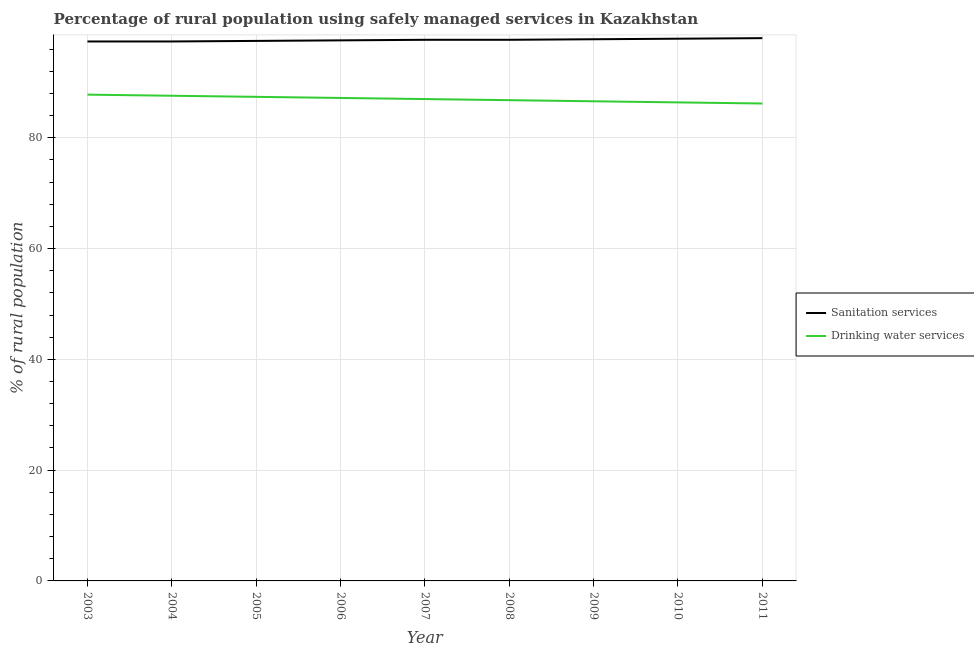What is the percentage of rural population who used drinking water services in 2006?
Offer a very short reply. 87.2. Across all years, what is the maximum percentage of rural population who used drinking water services?
Your response must be concise. 87.8. Across all years, what is the minimum percentage of rural population who used drinking water services?
Your answer should be very brief. 86.2. In which year was the percentage of rural population who used sanitation services minimum?
Your response must be concise. 2003. What is the total percentage of rural population who used drinking water services in the graph?
Offer a very short reply. 783. What is the difference between the percentage of rural population who used sanitation services in 2006 and that in 2010?
Your response must be concise. -0.3. What is the difference between the percentage of rural population who used drinking water services in 2010 and the percentage of rural population who used sanitation services in 2005?
Offer a very short reply. -11.1. What is the average percentage of rural population who used sanitation services per year?
Give a very brief answer. 97.67. In the year 2005, what is the difference between the percentage of rural population who used sanitation services and percentage of rural population who used drinking water services?
Your answer should be very brief. 10.1. What is the ratio of the percentage of rural population who used drinking water services in 2003 to that in 2009?
Ensure brevity in your answer.  1.01. What is the difference between the highest and the second highest percentage of rural population who used drinking water services?
Give a very brief answer. 0.2. What is the difference between the highest and the lowest percentage of rural population who used sanitation services?
Keep it short and to the point. 0.6. Does the percentage of rural population who used sanitation services monotonically increase over the years?
Your response must be concise. No. Is the percentage of rural population who used sanitation services strictly less than the percentage of rural population who used drinking water services over the years?
Offer a terse response. No. How many lines are there?
Offer a terse response. 2. How many years are there in the graph?
Offer a very short reply. 9. What is the difference between two consecutive major ticks on the Y-axis?
Give a very brief answer. 20. Does the graph contain grids?
Your answer should be very brief. Yes. How are the legend labels stacked?
Offer a very short reply. Vertical. What is the title of the graph?
Provide a short and direct response. Percentage of rural population using safely managed services in Kazakhstan. Does "Constant 2005 US$" appear as one of the legend labels in the graph?
Ensure brevity in your answer.  No. What is the label or title of the X-axis?
Keep it short and to the point. Year. What is the label or title of the Y-axis?
Your answer should be very brief. % of rural population. What is the % of rural population of Sanitation services in 2003?
Ensure brevity in your answer.  97.4. What is the % of rural population in Drinking water services in 2003?
Ensure brevity in your answer.  87.8. What is the % of rural population in Sanitation services in 2004?
Provide a short and direct response. 97.4. What is the % of rural population of Drinking water services in 2004?
Give a very brief answer. 87.6. What is the % of rural population of Sanitation services in 2005?
Provide a short and direct response. 97.5. What is the % of rural population of Drinking water services in 2005?
Make the answer very short. 87.4. What is the % of rural population in Sanitation services in 2006?
Give a very brief answer. 97.6. What is the % of rural population of Drinking water services in 2006?
Offer a terse response. 87.2. What is the % of rural population of Sanitation services in 2007?
Make the answer very short. 97.7. What is the % of rural population of Sanitation services in 2008?
Give a very brief answer. 97.7. What is the % of rural population in Drinking water services in 2008?
Ensure brevity in your answer.  86.8. What is the % of rural population in Sanitation services in 2009?
Ensure brevity in your answer.  97.8. What is the % of rural population in Drinking water services in 2009?
Offer a very short reply. 86.6. What is the % of rural population of Sanitation services in 2010?
Offer a very short reply. 97.9. What is the % of rural population of Drinking water services in 2010?
Your answer should be very brief. 86.4. What is the % of rural population in Drinking water services in 2011?
Provide a short and direct response. 86.2. Across all years, what is the maximum % of rural population in Sanitation services?
Your answer should be compact. 98. Across all years, what is the maximum % of rural population of Drinking water services?
Offer a terse response. 87.8. Across all years, what is the minimum % of rural population in Sanitation services?
Ensure brevity in your answer.  97.4. Across all years, what is the minimum % of rural population in Drinking water services?
Make the answer very short. 86.2. What is the total % of rural population in Sanitation services in the graph?
Offer a very short reply. 879. What is the total % of rural population of Drinking water services in the graph?
Keep it short and to the point. 783. What is the difference between the % of rural population of Sanitation services in 2003 and that in 2004?
Ensure brevity in your answer.  0. What is the difference between the % of rural population of Sanitation services in 2003 and that in 2005?
Your answer should be very brief. -0.1. What is the difference between the % of rural population in Sanitation services in 2003 and that in 2008?
Provide a short and direct response. -0.3. What is the difference between the % of rural population of Drinking water services in 2003 and that in 2008?
Provide a succinct answer. 1. What is the difference between the % of rural population of Sanitation services in 2003 and that in 2010?
Your response must be concise. -0.5. What is the difference between the % of rural population in Drinking water services in 2003 and that in 2011?
Your response must be concise. 1.6. What is the difference between the % of rural population in Sanitation services in 2004 and that in 2005?
Give a very brief answer. -0.1. What is the difference between the % of rural population in Drinking water services in 2004 and that in 2007?
Make the answer very short. 0.6. What is the difference between the % of rural population of Sanitation services in 2004 and that in 2008?
Your answer should be compact. -0.3. What is the difference between the % of rural population of Drinking water services in 2004 and that in 2008?
Make the answer very short. 0.8. What is the difference between the % of rural population of Drinking water services in 2004 and that in 2009?
Offer a very short reply. 1. What is the difference between the % of rural population in Sanitation services in 2004 and that in 2011?
Give a very brief answer. -0.6. What is the difference between the % of rural population in Drinking water services in 2004 and that in 2011?
Make the answer very short. 1.4. What is the difference between the % of rural population in Sanitation services in 2005 and that in 2007?
Offer a terse response. -0.2. What is the difference between the % of rural population of Drinking water services in 2005 and that in 2007?
Provide a short and direct response. 0.4. What is the difference between the % of rural population of Drinking water services in 2005 and that in 2008?
Your answer should be compact. 0.6. What is the difference between the % of rural population of Sanitation services in 2005 and that in 2009?
Provide a short and direct response. -0.3. What is the difference between the % of rural population in Drinking water services in 2005 and that in 2009?
Provide a short and direct response. 0.8. What is the difference between the % of rural population of Sanitation services in 2006 and that in 2007?
Keep it short and to the point. -0.1. What is the difference between the % of rural population in Drinking water services in 2006 and that in 2007?
Keep it short and to the point. 0.2. What is the difference between the % of rural population in Sanitation services in 2006 and that in 2008?
Give a very brief answer. -0.1. What is the difference between the % of rural population of Sanitation services in 2006 and that in 2009?
Offer a terse response. -0.2. What is the difference between the % of rural population in Sanitation services in 2006 and that in 2011?
Make the answer very short. -0.4. What is the difference between the % of rural population in Drinking water services in 2006 and that in 2011?
Ensure brevity in your answer.  1. What is the difference between the % of rural population in Drinking water services in 2007 and that in 2008?
Ensure brevity in your answer.  0.2. What is the difference between the % of rural population in Drinking water services in 2007 and that in 2009?
Your answer should be compact. 0.4. What is the difference between the % of rural population of Drinking water services in 2007 and that in 2010?
Offer a terse response. 0.6. What is the difference between the % of rural population of Sanitation services in 2007 and that in 2011?
Keep it short and to the point. -0.3. What is the difference between the % of rural population in Drinking water services in 2008 and that in 2009?
Provide a succinct answer. 0.2. What is the difference between the % of rural population in Sanitation services in 2008 and that in 2010?
Keep it short and to the point. -0.2. What is the difference between the % of rural population in Sanitation services in 2008 and that in 2011?
Your answer should be very brief. -0.3. What is the difference between the % of rural population of Drinking water services in 2008 and that in 2011?
Ensure brevity in your answer.  0.6. What is the difference between the % of rural population of Drinking water services in 2009 and that in 2010?
Provide a succinct answer. 0.2. What is the difference between the % of rural population in Sanitation services in 2009 and that in 2011?
Offer a very short reply. -0.2. What is the difference between the % of rural population in Drinking water services in 2009 and that in 2011?
Your response must be concise. 0.4. What is the difference between the % of rural population in Sanitation services in 2010 and that in 2011?
Make the answer very short. -0.1. What is the difference between the % of rural population in Drinking water services in 2010 and that in 2011?
Keep it short and to the point. 0.2. What is the difference between the % of rural population in Sanitation services in 2003 and the % of rural population in Drinking water services in 2004?
Ensure brevity in your answer.  9.8. What is the difference between the % of rural population of Sanitation services in 2003 and the % of rural population of Drinking water services in 2005?
Provide a short and direct response. 10. What is the difference between the % of rural population of Sanitation services in 2003 and the % of rural population of Drinking water services in 2007?
Provide a succinct answer. 10.4. What is the difference between the % of rural population of Sanitation services in 2003 and the % of rural population of Drinking water services in 2009?
Make the answer very short. 10.8. What is the difference between the % of rural population in Sanitation services in 2004 and the % of rural population in Drinking water services in 2005?
Your answer should be compact. 10. What is the difference between the % of rural population of Sanitation services in 2004 and the % of rural population of Drinking water services in 2007?
Offer a terse response. 10.4. What is the difference between the % of rural population of Sanitation services in 2004 and the % of rural population of Drinking water services in 2008?
Offer a terse response. 10.6. What is the difference between the % of rural population in Sanitation services in 2004 and the % of rural population in Drinking water services in 2009?
Provide a short and direct response. 10.8. What is the difference between the % of rural population of Sanitation services in 2004 and the % of rural population of Drinking water services in 2010?
Offer a terse response. 11. What is the difference between the % of rural population of Sanitation services in 2004 and the % of rural population of Drinking water services in 2011?
Provide a succinct answer. 11.2. What is the difference between the % of rural population of Sanitation services in 2005 and the % of rural population of Drinking water services in 2006?
Make the answer very short. 10.3. What is the difference between the % of rural population in Sanitation services in 2005 and the % of rural population in Drinking water services in 2009?
Make the answer very short. 10.9. What is the difference between the % of rural population of Sanitation services in 2006 and the % of rural population of Drinking water services in 2008?
Make the answer very short. 10.8. What is the difference between the % of rural population in Sanitation services in 2006 and the % of rural population in Drinking water services in 2009?
Give a very brief answer. 11. What is the difference between the % of rural population in Sanitation services in 2007 and the % of rural population in Drinking water services in 2008?
Your response must be concise. 10.9. What is the difference between the % of rural population of Sanitation services in 2008 and the % of rural population of Drinking water services in 2009?
Ensure brevity in your answer.  11.1. What is the difference between the % of rural population of Sanitation services in 2008 and the % of rural population of Drinking water services in 2010?
Give a very brief answer. 11.3. What is the difference between the % of rural population in Sanitation services in 2008 and the % of rural population in Drinking water services in 2011?
Offer a terse response. 11.5. What is the difference between the % of rural population of Sanitation services in 2009 and the % of rural population of Drinking water services in 2011?
Keep it short and to the point. 11.6. What is the difference between the % of rural population in Sanitation services in 2010 and the % of rural population in Drinking water services in 2011?
Offer a very short reply. 11.7. What is the average % of rural population of Sanitation services per year?
Ensure brevity in your answer.  97.67. In the year 2004, what is the difference between the % of rural population of Sanitation services and % of rural population of Drinking water services?
Make the answer very short. 9.8. In the year 2006, what is the difference between the % of rural population of Sanitation services and % of rural population of Drinking water services?
Offer a very short reply. 10.4. In the year 2007, what is the difference between the % of rural population of Sanitation services and % of rural population of Drinking water services?
Offer a very short reply. 10.7. In the year 2009, what is the difference between the % of rural population of Sanitation services and % of rural population of Drinking water services?
Provide a short and direct response. 11.2. In the year 2011, what is the difference between the % of rural population in Sanitation services and % of rural population in Drinking water services?
Keep it short and to the point. 11.8. What is the ratio of the % of rural population of Drinking water services in 2003 to that in 2005?
Your answer should be very brief. 1. What is the ratio of the % of rural population of Drinking water services in 2003 to that in 2006?
Ensure brevity in your answer.  1.01. What is the ratio of the % of rural population in Sanitation services in 2003 to that in 2007?
Offer a very short reply. 1. What is the ratio of the % of rural population of Drinking water services in 2003 to that in 2007?
Provide a short and direct response. 1.01. What is the ratio of the % of rural population of Drinking water services in 2003 to that in 2008?
Offer a terse response. 1.01. What is the ratio of the % of rural population of Sanitation services in 2003 to that in 2009?
Provide a succinct answer. 1. What is the ratio of the % of rural population of Drinking water services in 2003 to that in 2009?
Keep it short and to the point. 1.01. What is the ratio of the % of rural population of Drinking water services in 2003 to that in 2010?
Keep it short and to the point. 1.02. What is the ratio of the % of rural population in Sanitation services in 2003 to that in 2011?
Ensure brevity in your answer.  0.99. What is the ratio of the % of rural population in Drinking water services in 2003 to that in 2011?
Provide a short and direct response. 1.02. What is the ratio of the % of rural population of Sanitation services in 2004 to that in 2005?
Give a very brief answer. 1. What is the ratio of the % of rural population of Sanitation services in 2004 to that in 2006?
Ensure brevity in your answer.  1. What is the ratio of the % of rural population in Drinking water services in 2004 to that in 2006?
Your response must be concise. 1. What is the ratio of the % of rural population of Sanitation services in 2004 to that in 2007?
Offer a terse response. 1. What is the ratio of the % of rural population in Sanitation services in 2004 to that in 2008?
Your response must be concise. 1. What is the ratio of the % of rural population of Drinking water services in 2004 to that in 2008?
Provide a succinct answer. 1.01. What is the ratio of the % of rural population in Drinking water services in 2004 to that in 2009?
Offer a terse response. 1.01. What is the ratio of the % of rural population in Sanitation services in 2004 to that in 2010?
Give a very brief answer. 0.99. What is the ratio of the % of rural population of Drinking water services in 2004 to that in 2010?
Ensure brevity in your answer.  1.01. What is the ratio of the % of rural population of Drinking water services in 2004 to that in 2011?
Your response must be concise. 1.02. What is the ratio of the % of rural population of Sanitation services in 2005 to that in 2006?
Give a very brief answer. 1. What is the ratio of the % of rural population in Sanitation services in 2005 to that in 2007?
Ensure brevity in your answer.  1. What is the ratio of the % of rural population in Drinking water services in 2005 to that in 2007?
Keep it short and to the point. 1. What is the ratio of the % of rural population of Sanitation services in 2005 to that in 2008?
Your answer should be very brief. 1. What is the ratio of the % of rural population in Drinking water services in 2005 to that in 2009?
Ensure brevity in your answer.  1.01. What is the ratio of the % of rural population in Drinking water services in 2005 to that in 2010?
Offer a terse response. 1.01. What is the ratio of the % of rural population of Drinking water services in 2005 to that in 2011?
Give a very brief answer. 1.01. What is the ratio of the % of rural population in Sanitation services in 2006 to that in 2007?
Ensure brevity in your answer.  1. What is the ratio of the % of rural population in Drinking water services in 2006 to that in 2007?
Offer a very short reply. 1. What is the ratio of the % of rural population in Drinking water services in 2006 to that in 2009?
Give a very brief answer. 1.01. What is the ratio of the % of rural population of Sanitation services in 2006 to that in 2010?
Keep it short and to the point. 1. What is the ratio of the % of rural population of Drinking water services in 2006 to that in 2010?
Your answer should be very brief. 1.01. What is the ratio of the % of rural population in Sanitation services in 2006 to that in 2011?
Make the answer very short. 1. What is the ratio of the % of rural population of Drinking water services in 2006 to that in 2011?
Your answer should be compact. 1.01. What is the ratio of the % of rural population of Sanitation services in 2007 to that in 2008?
Ensure brevity in your answer.  1. What is the ratio of the % of rural population in Drinking water services in 2007 to that in 2008?
Your answer should be compact. 1. What is the ratio of the % of rural population of Sanitation services in 2007 to that in 2010?
Ensure brevity in your answer.  1. What is the ratio of the % of rural population in Drinking water services in 2007 to that in 2011?
Offer a very short reply. 1.01. What is the ratio of the % of rural population of Sanitation services in 2008 to that in 2009?
Offer a terse response. 1. What is the ratio of the % of rural population in Drinking water services in 2008 to that in 2009?
Your answer should be very brief. 1. What is the ratio of the % of rural population of Sanitation services in 2008 to that in 2011?
Offer a very short reply. 1. What is the ratio of the % of rural population of Drinking water services in 2008 to that in 2011?
Provide a succinct answer. 1.01. What is the ratio of the % of rural population of Drinking water services in 2009 to that in 2011?
Your answer should be very brief. 1. What is the ratio of the % of rural population of Sanitation services in 2010 to that in 2011?
Offer a very short reply. 1. What is the ratio of the % of rural population of Drinking water services in 2010 to that in 2011?
Your answer should be very brief. 1. What is the difference between the highest and the second highest % of rural population in Sanitation services?
Offer a very short reply. 0.1. What is the difference between the highest and the second highest % of rural population of Drinking water services?
Offer a terse response. 0.2. What is the difference between the highest and the lowest % of rural population in Drinking water services?
Give a very brief answer. 1.6. 